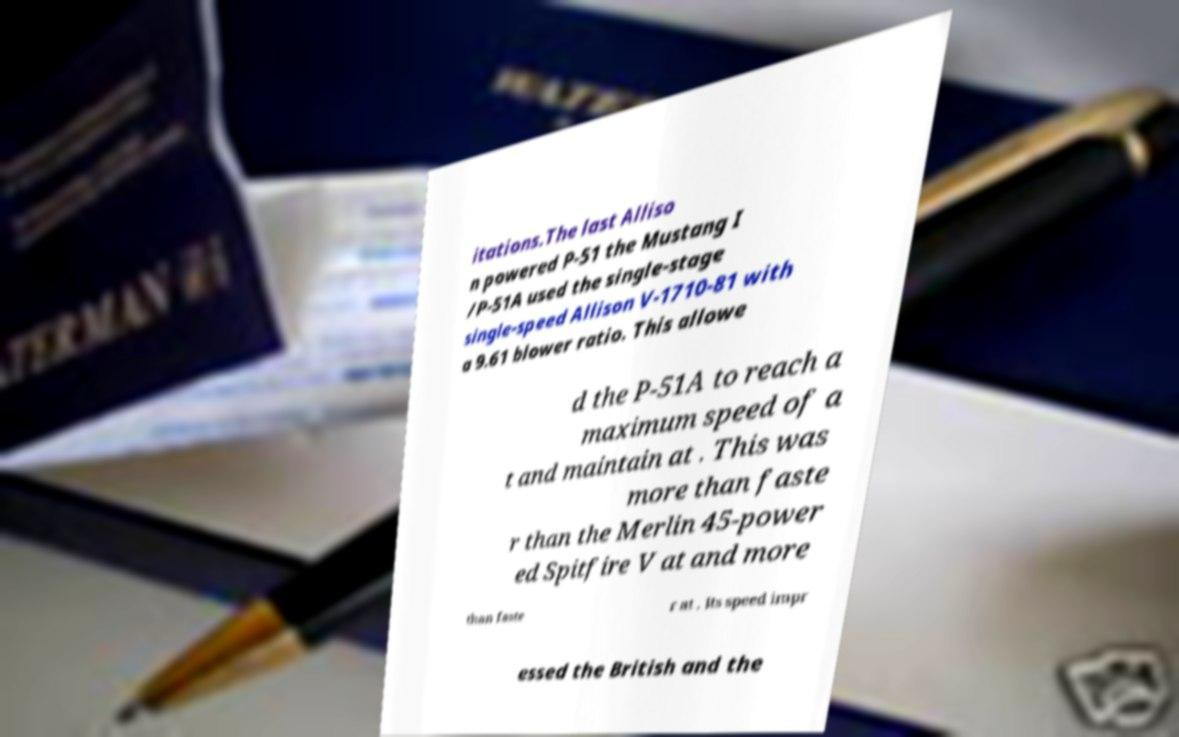Could you assist in decoding the text presented in this image and type it out clearly? itations.The last Alliso n powered P-51 the Mustang I /P-51A used the single-stage single-speed Allison V-1710-81 with a 9.61 blower ratio. This allowe d the P-51A to reach a maximum speed of a t and maintain at . This was more than faste r than the Merlin 45-power ed Spitfire V at and more than faste r at . Its speed impr essed the British and the 